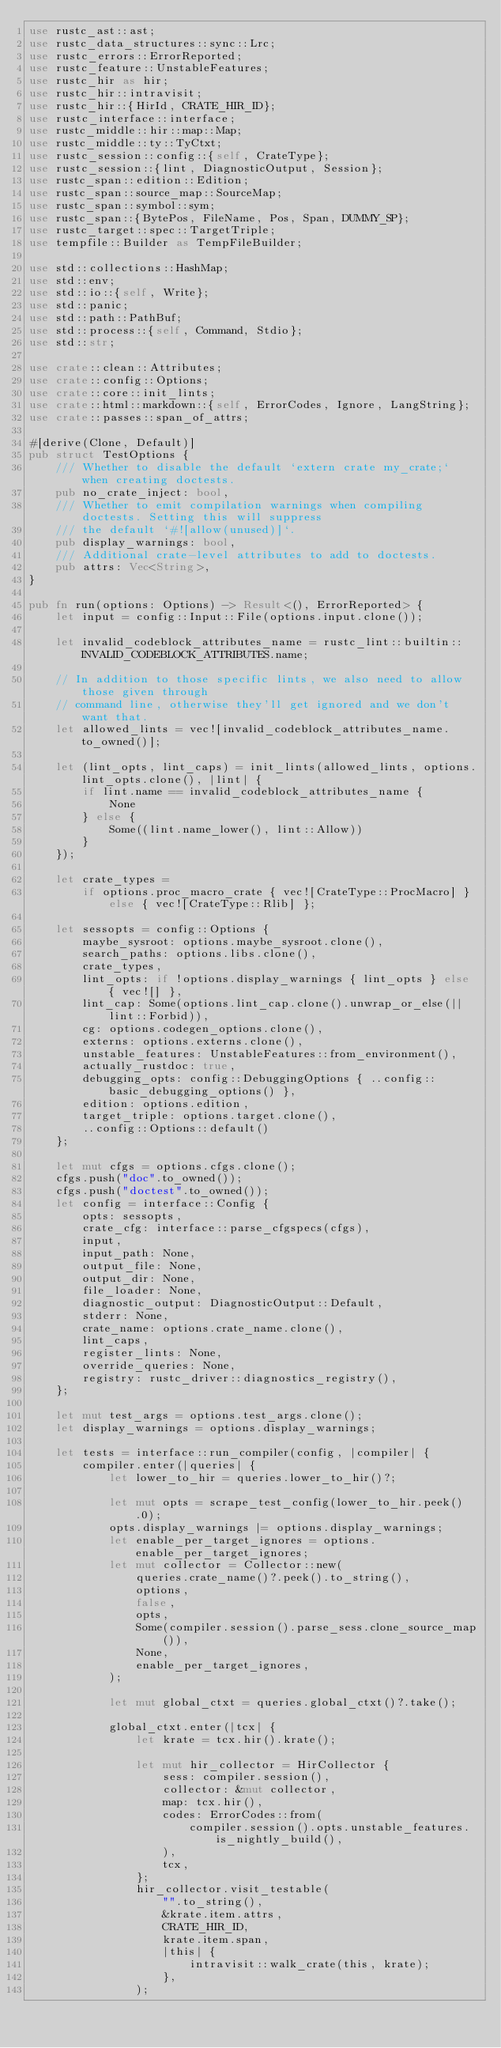Convert code to text. <code><loc_0><loc_0><loc_500><loc_500><_Rust_>use rustc_ast::ast;
use rustc_data_structures::sync::Lrc;
use rustc_errors::ErrorReported;
use rustc_feature::UnstableFeatures;
use rustc_hir as hir;
use rustc_hir::intravisit;
use rustc_hir::{HirId, CRATE_HIR_ID};
use rustc_interface::interface;
use rustc_middle::hir::map::Map;
use rustc_middle::ty::TyCtxt;
use rustc_session::config::{self, CrateType};
use rustc_session::{lint, DiagnosticOutput, Session};
use rustc_span::edition::Edition;
use rustc_span::source_map::SourceMap;
use rustc_span::symbol::sym;
use rustc_span::{BytePos, FileName, Pos, Span, DUMMY_SP};
use rustc_target::spec::TargetTriple;
use tempfile::Builder as TempFileBuilder;

use std::collections::HashMap;
use std::env;
use std::io::{self, Write};
use std::panic;
use std::path::PathBuf;
use std::process::{self, Command, Stdio};
use std::str;

use crate::clean::Attributes;
use crate::config::Options;
use crate::core::init_lints;
use crate::html::markdown::{self, ErrorCodes, Ignore, LangString};
use crate::passes::span_of_attrs;

#[derive(Clone, Default)]
pub struct TestOptions {
    /// Whether to disable the default `extern crate my_crate;` when creating doctests.
    pub no_crate_inject: bool,
    /// Whether to emit compilation warnings when compiling doctests. Setting this will suppress
    /// the default `#![allow(unused)]`.
    pub display_warnings: bool,
    /// Additional crate-level attributes to add to doctests.
    pub attrs: Vec<String>,
}

pub fn run(options: Options) -> Result<(), ErrorReported> {
    let input = config::Input::File(options.input.clone());

    let invalid_codeblock_attributes_name = rustc_lint::builtin::INVALID_CODEBLOCK_ATTRIBUTES.name;

    // In addition to those specific lints, we also need to allow those given through
    // command line, otherwise they'll get ignored and we don't want that.
    let allowed_lints = vec![invalid_codeblock_attributes_name.to_owned()];

    let (lint_opts, lint_caps) = init_lints(allowed_lints, options.lint_opts.clone(), |lint| {
        if lint.name == invalid_codeblock_attributes_name {
            None
        } else {
            Some((lint.name_lower(), lint::Allow))
        }
    });

    let crate_types =
        if options.proc_macro_crate { vec![CrateType::ProcMacro] } else { vec![CrateType::Rlib] };

    let sessopts = config::Options {
        maybe_sysroot: options.maybe_sysroot.clone(),
        search_paths: options.libs.clone(),
        crate_types,
        lint_opts: if !options.display_warnings { lint_opts } else { vec![] },
        lint_cap: Some(options.lint_cap.clone().unwrap_or_else(|| lint::Forbid)),
        cg: options.codegen_options.clone(),
        externs: options.externs.clone(),
        unstable_features: UnstableFeatures::from_environment(),
        actually_rustdoc: true,
        debugging_opts: config::DebuggingOptions { ..config::basic_debugging_options() },
        edition: options.edition,
        target_triple: options.target.clone(),
        ..config::Options::default()
    };

    let mut cfgs = options.cfgs.clone();
    cfgs.push("doc".to_owned());
    cfgs.push("doctest".to_owned());
    let config = interface::Config {
        opts: sessopts,
        crate_cfg: interface::parse_cfgspecs(cfgs),
        input,
        input_path: None,
        output_file: None,
        output_dir: None,
        file_loader: None,
        diagnostic_output: DiagnosticOutput::Default,
        stderr: None,
        crate_name: options.crate_name.clone(),
        lint_caps,
        register_lints: None,
        override_queries: None,
        registry: rustc_driver::diagnostics_registry(),
    };

    let mut test_args = options.test_args.clone();
    let display_warnings = options.display_warnings;

    let tests = interface::run_compiler(config, |compiler| {
        compiler.enter(|queries| {
            let lower_to_hir = queries.lower_to_hir()?;

            let mut opts = scrape_test_config(lower_to_hir.peek().0);
            opts.display_warnings |= options.display_warnings;
            let enable_per_target_ignores = options.enable_per_target_ignores;
            let mut collector = Collector::new(
                queries.crate_name()?.peek().to_string(),
                options,
                false,
                opts,
                Some(compiler.session().parse_sess.clone_source_map()),
                None,
                enable_per_target_ignores,
            );

            let mut global_ctxt = queries.global_ctxt()?.take();

            global_ctxt.enter(|tcx| {
                let krate = tcx.hir().krate();

                let mut hir_collector = HirCollector {
                    sess: compiler.session(),
                    collector: &mut collector,
                    map: tcx.hir(),
                    codes: ErrorCodes::from(
                        compiler.session().opts.unstable_features.is_nightly_build(),
                    ),
                    tcx,
                };
                hir_collector.visit_testable(
                    "".to_string(),
                    &krate.item.attrs,
                    CRATE_HIR_ID,
                    krate.item.span,
                    |this| {
                        intravisit::walk_crate(this, krate);
                    },
                );</code> 